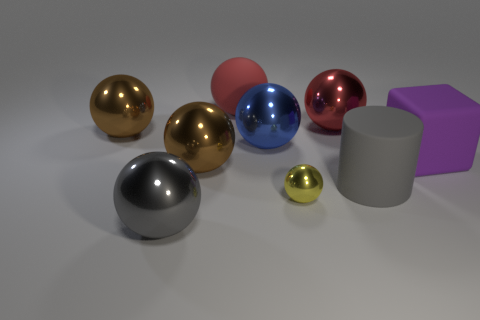Is there anything else that has the same size as the yellow thing?
Give a very brief answer. No. Is there anything else that is the same shape as the purple object?
Offer a terse response. No. What number of other things are the same color as the large matte ball?
Provide a short and direct response. 1. There is a purple object that is the same size as the matte cylinder; what shape is it?
Ensure brevity in your answer.  Cube. How many tiny things are either blue rubber blocks or red matte spheres?
Keep it short and to the point. 0. Is there a large metal ball to the left of the brown thing right of the big gray object that is on the left side of the cylinder?
Ensure brevity in your answer.  Yes. Are there any cubes that have the same size as the matte cylinder?
Your answer should be very brief. Yes. There is a blue sphere that is the same size as the purple thing; what is it made of?
Offer a very short reply. Metal. There is a block; is it the same size as the shiny thing in front of the small yellow ball?
Your response must be concise. Yes. How many rubber things are either big red spheres or blue objects?
Make the answer very short. 1. 